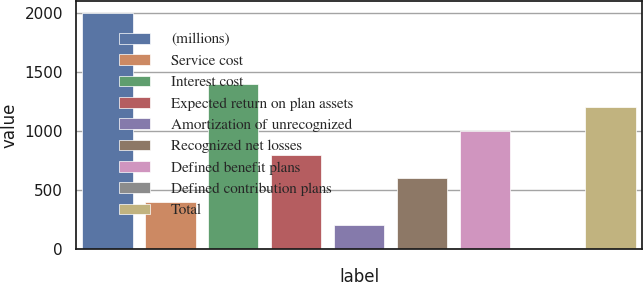Convert chart. <chart><loc_0><loc_0><loc_500><loc_500><bar_chart><fcel>(millions)<fcel>Service cost<fcel>Interest cost<fcel>Expected return on plan assets<fcel>Amortization of unrecognized<fcel>Recognized net losses<fcel>Defined benefit plans<fcel>Defined contribution plans<fcel>Total<nl><fcel>2004<fcel>402.24<fcel>1403.34<fcel>802.68<fcel>202.02<fcel>602.46<fcel>1002.9<fcel>1.8<fcel>1203.12<nl></chart> 